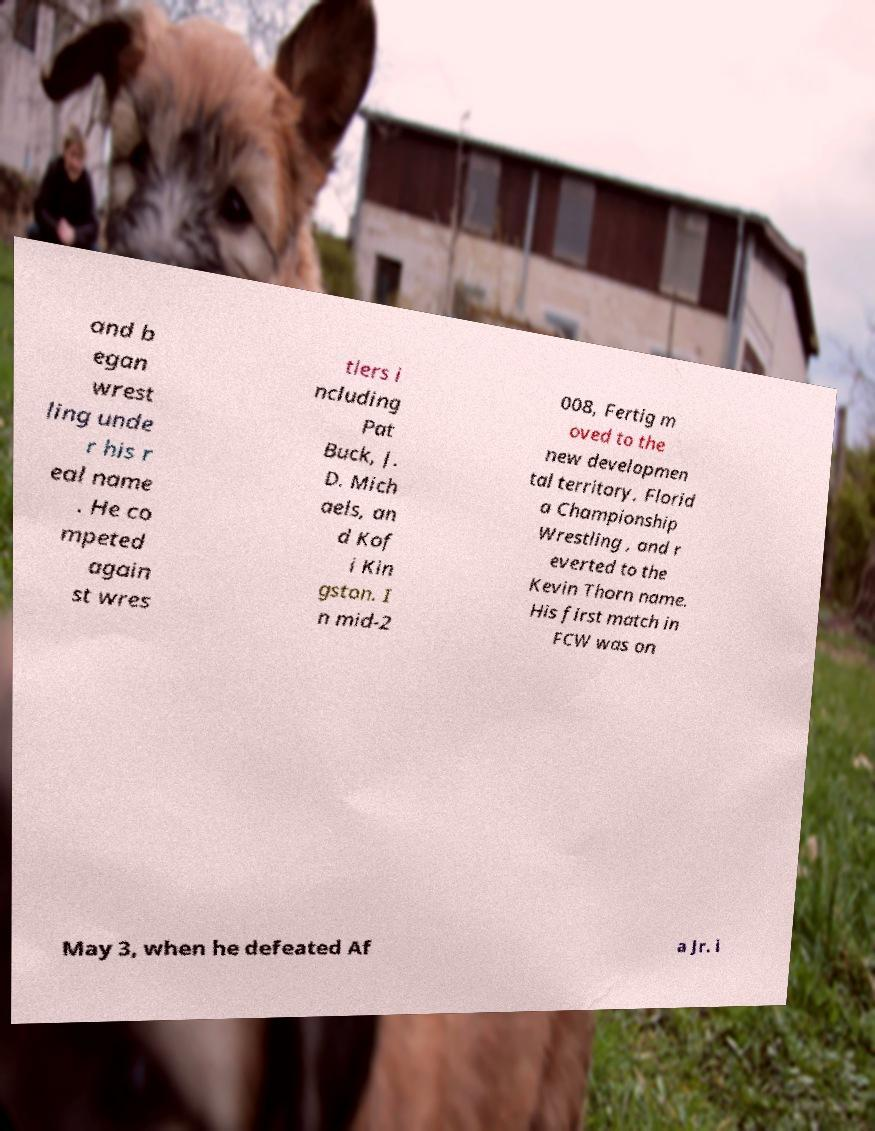Please identify and transcribe the text found in this image. and b egan wrest ling unde r his r eal name . He co mpeted again st wres tlers i ncluding Pat Buck, J. D. Mich aels, an d Kof i Kin gston. I n mid-2 008, Fertig m oved to the new developmen tal territory, Florid a Championship Wrestling , and r everted to the Kevin Thorn name. His first match in FCW was on May 3, when he defeated Af a Jr. i 